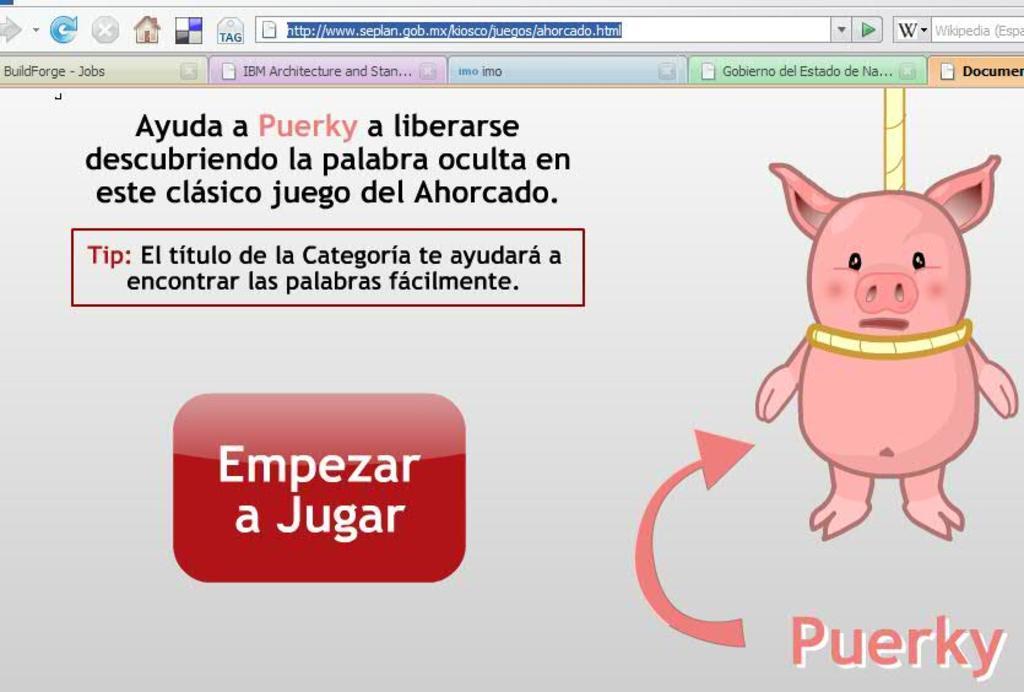Could you give a brief overview of what you see in this image? In this picture I can see a web page, there are folders, icons, there is a search bar, there are words and there is a cartoon pig hanging with a rope. 